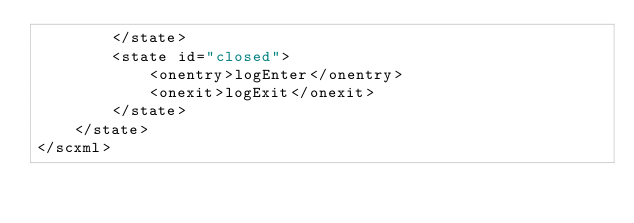Convert code to text. <code><loc_0><loc_0><loc_500><loc_500><_XML_>        </state>
        <state id="closed">
            <onentry>logEnter</onentry>
            <onexit>logExit</onexit>
        </state>
    </state>
</scxml>
</code> 